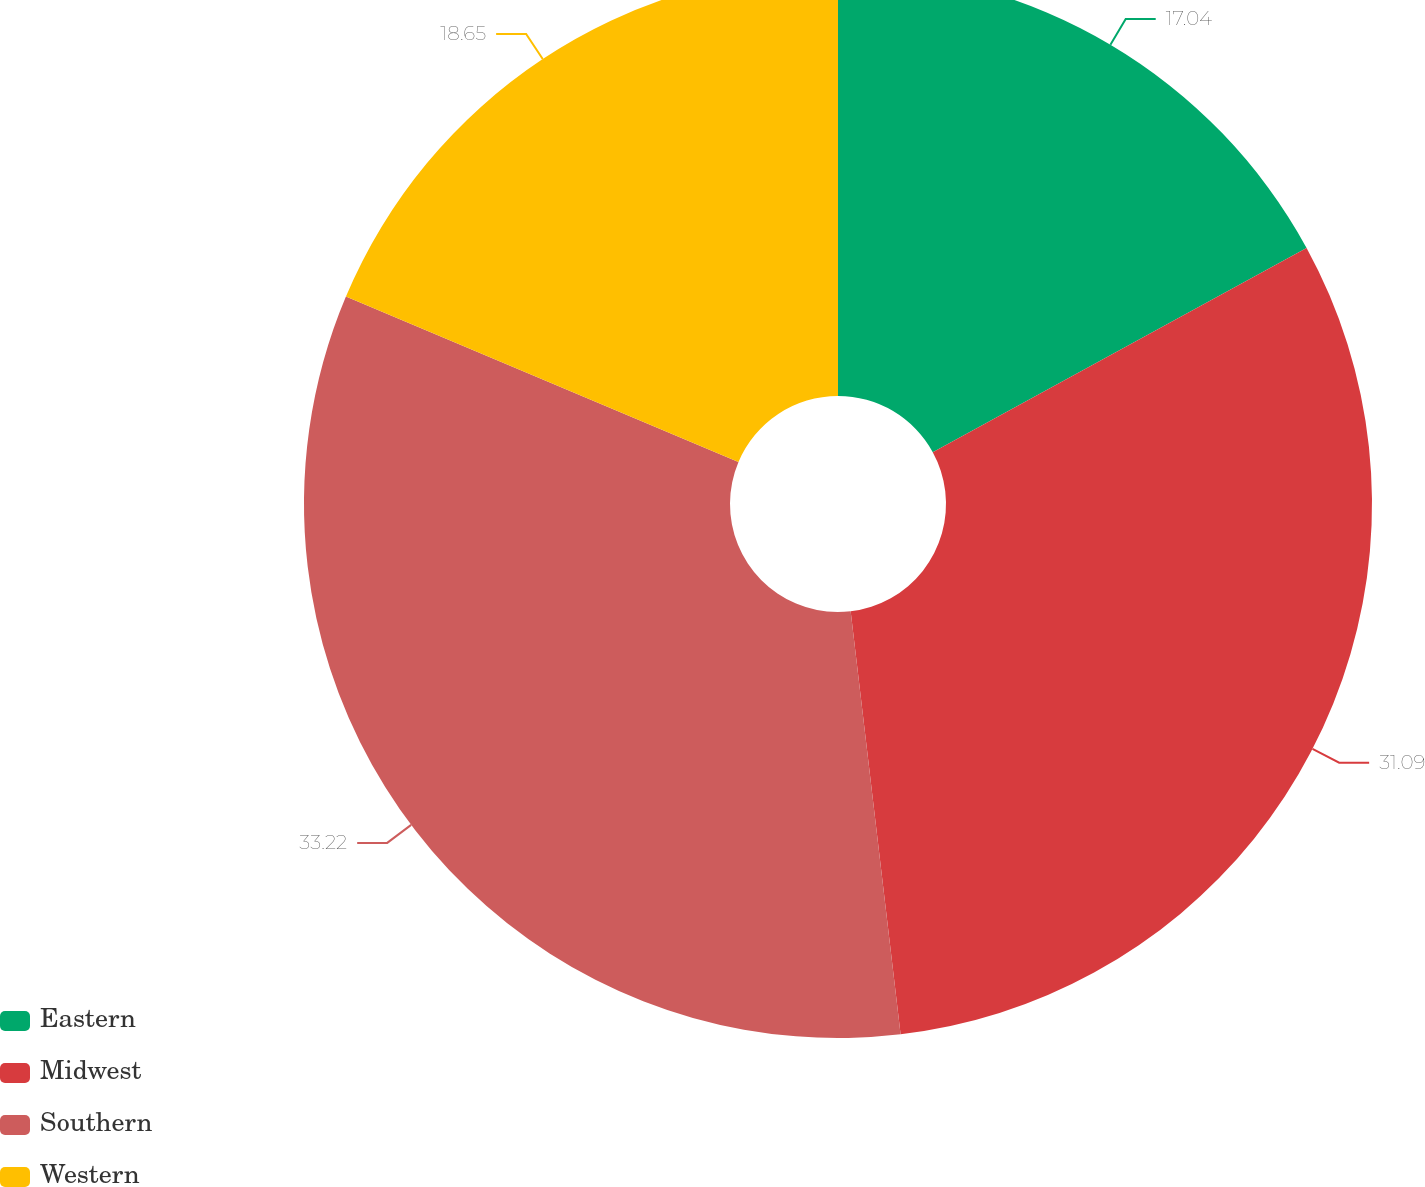<chart> <loc_0><loc_0><loc_500><loc_500><pie_chart><fcel>Eastern<fcel>Midwest<fcel>Southern<fcel>Western<nl><fcel>17.04%<fcel>31.09%<fcel>33.22%<fcel>18.65%<nl></chart> 